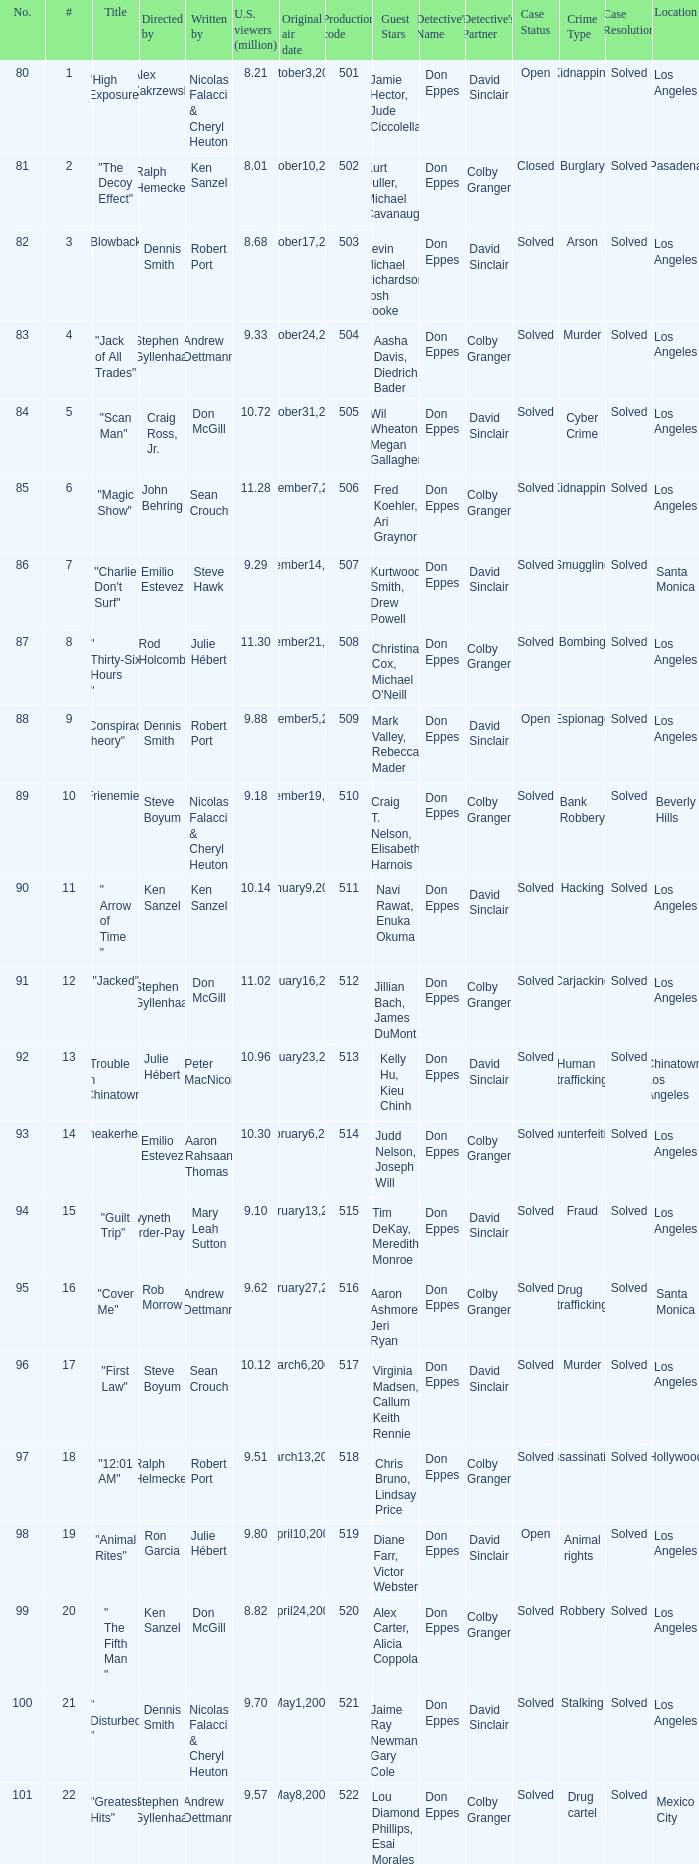What episode had 10.14 million viewers (U.S.)? 11.0. 